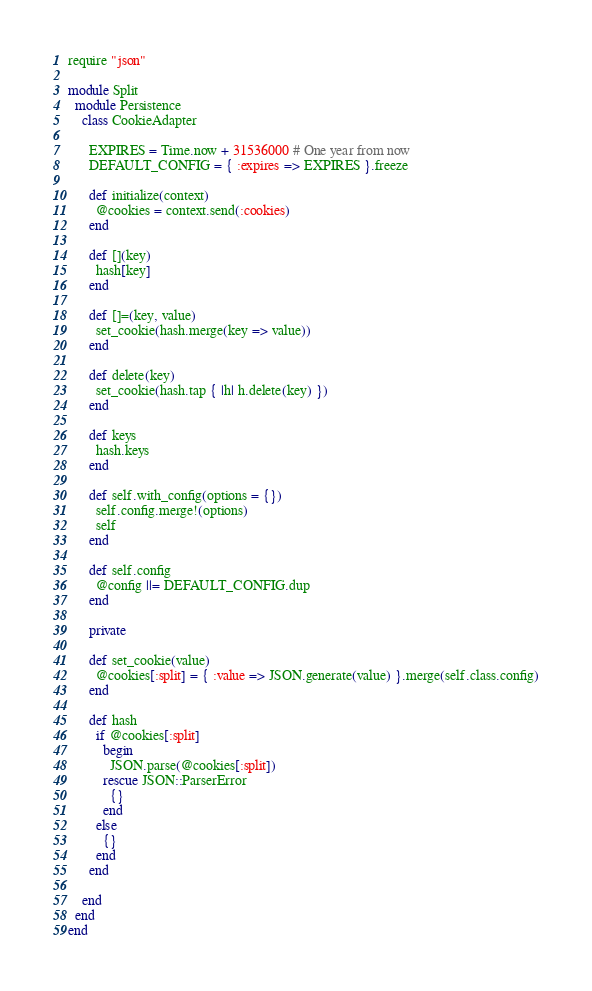Convert code to text. <code><loc_0><loc_0><loc_500><loc_500><_Ruby_>require "json"

module Split
  module Persistence
    class CookieAdapter

      EXPIRES = Time.now + 31536000 # One year from now
      DEFAULT_CONFIG = { :expires => EXPIRES }.freeze

      def initialize(context)
        @cookies = context.send(:cookies)
      end

      def [](key)
        hash[key]
      end

      def []=(key, value)
        set_cookie(hash.merge(key => value))
      end

      def delete(key)
        set_cookie(hash.tap { |h| h.delete(key) })
      end

      def keys
        hash.keys
      end

      def self.with_config(options = {})
        self.config.merge!(options)
        self
      end

      def self.config
        @config ||= DEFAULT_CONFIG.dup
      end

      private

      def set_cookie(value)
        @cookies[:split] = { :value => JSON.generate(value) }.merge(self.class.config)
      end

      def hash
        if @cookies[:split]
          begin
            JSON.parse(@cookies[:split])
          rescue JSON::ParserError
            {}
          end
        else
          {}
        end
      end

    end
  end
end
</code> 